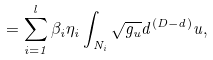Convert formula to latex. <formula><loc_0><loc_0><loc_500><loc_500>= \sum _ { i = 1 } ^ { l } \beta _ { i } \eta _ { i } \int _ { N _ { i } } \sqrt { g _ { u } } d ^ { ( D - d ) } u ,</formula> 